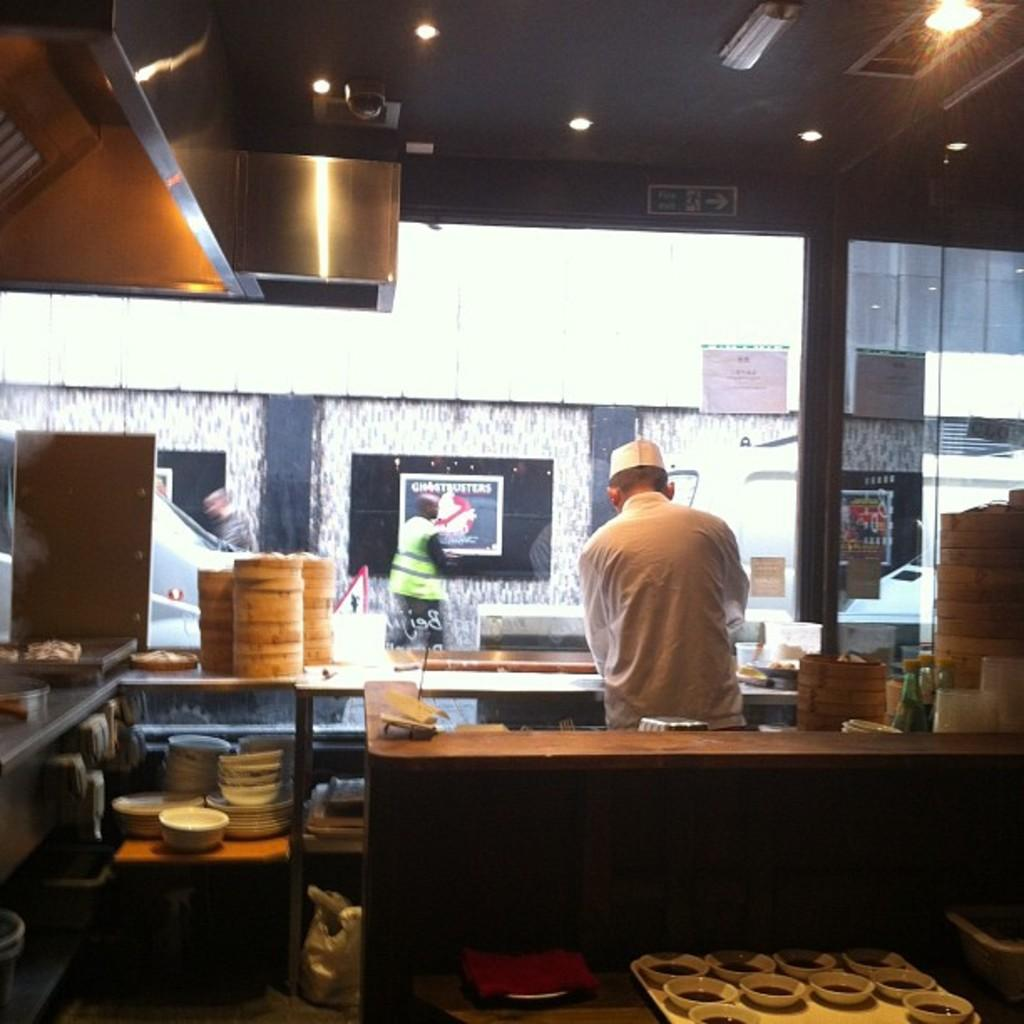Who is present in the image? There is a man in the image. What is on the desk in the image? There are bowls on the desk. What is inside the bowls? There are items in the bowls. What can be seen in the image that provides illumination? There are lights visible in the image. What action is the man taking in the image? The provided facts do not mention any specific action the man is taking in the image. 